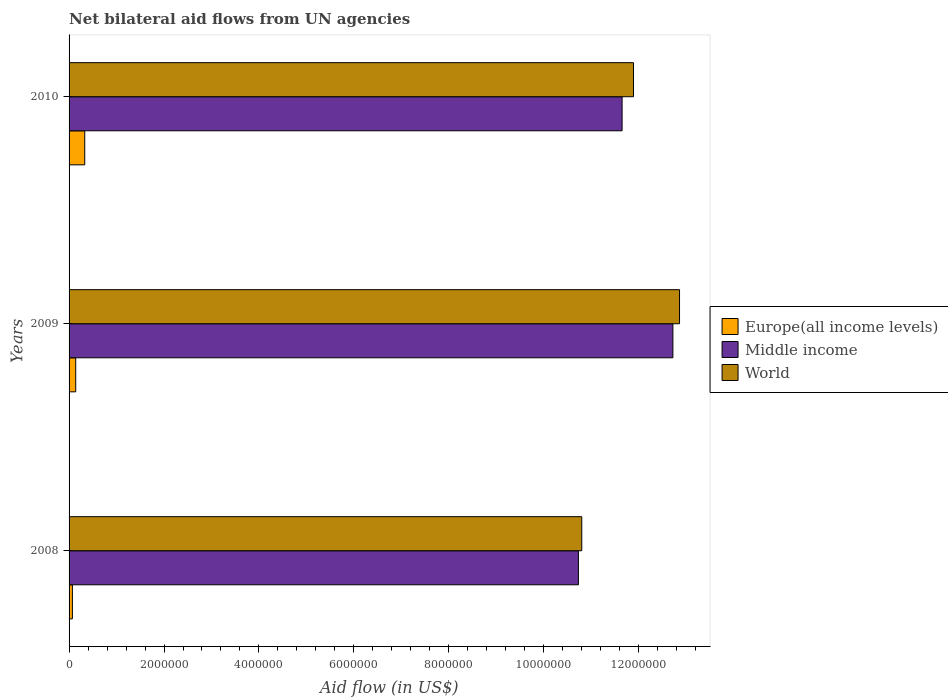Are the number of bars per tick equal to the number of legend labels?
Provide a short and direct response. Yes. Are the number of bars on each tick of the Y-axis equal?
Offer a terse response. Yes. What is the label of the 2nd group of bars from the top?
Offer a terse response. 2009. In how many cases, is the number of bars for a given year not equal to the number of legend labels?
Keep it short and to the point. 0. What is the net bilateral aid flow in Middle income in 2008?
Ensure brevity in your answer.  1.07e+07. Across all years, what is the maximum net bilateral aid flow in Europe(all income levels)?
Offer a very short reply. 3.30e+05. Across all years, what is the minimum net bilateral aid flow in World?
Make the answer very short. 1.08e+07. In which year was the net bilateral aid flow in World maximum?
Ensure brevity in your answer.  2009. What is the total net bilateral aid flow in Europe(all income levels) in the graph?
Provide a short and direct response. 5.40e+05. What is the difference between the net bilateral aid flow in Europe(all income levels) in 2008 and that in 2009?
Your answer should be compact. -7.00e+04. What is the difference between the net bilateral aid flow in World in 2010 and the net bilateral aid flow in Middle income in 2008?
Give a very brief answer. 1.16e+06. In the year 2009, what is the difference between the net bilateral aid flow in Europe(all income levels) and net bilateral aid flow in Middle income?
Offer a very short reply. -1.26e+07. In how many years, is the net bilateral aid flow in Europe(all income levels) greater than 800000 US$?
Offer a very short reply. 0. What is the ratio of the net bilateral aid flow in World in 2008 to that in 2009?
Your answer should be compact. 0.84. Is the difference between the net bilateral aid flow in Europe(all income levels) in 2009 and 2010 greater than the difference between the net bilateral aid flow in Middle income in 2009 and 2010?
Offer a very short reply. No. What is the difference between the highest and the lowest net bilateral aid flow in Europe(all income levels)?
Your answer should be compact. 2.60e+05. What does the 1st bar from the top in 2009 represents?
Your answer should be compact. World. Is it the case that in every year, the sum of the net bilateral aid flow in Europe(all income levels) and net bilateral aid flow in World is greater than the net bilateral aid flow in Middle income?
Offer a very short reply. Yes. How many bars are there?
Make the answer very short. 9. Are all the bars in the graph horizontal?
Your response must be concise. Yes. Does the graph contain any zero values?
Your answer should be compact. No. Does the graph contain grids?
Your answer should be compact. No. Where does the legend appear in the graph?
Offer a terse response. Center right. How many legend labels are there?
Your answer should be compact. 3. What is the title of the graph?
Ensure brevity in your answer.  Net bilateral aid flows from UN agencies. Does "Paraguay" appear as one of the legend labels in the graph?
Give a very brief answer. No. What is the label or title of the X-axis?
Ensure brevity in your answer.  Aid flow (in US$). What is the label or title of the Y-axis?
Your answer should be compact. Years. What is the Aid flow (in US$) of Europe(all income levels) in 2008?
Make the answer very short. 7.00e+04. What is the Aid flow (in US$) of Middle income in 2008?
Your answer should be compact. 1.07e+07. What is the Aid flow (in US$) of World in 2008?
Give a very brief answer. 1.08e+07. What is the Aid flow (in US$) of Europe(all income levels) in 2009?
Ensure brevity in your answer.  1.40e+05. What is the Aid flow (in US$) in Middle income in 2009?
Offer a very short reply. 1.27e+07. What is the Aid flow (in US$) in World in 2009?
Provide a short and direct response. 1.29e+07. What is the Aid flow (in US$) in Europe(all income levels) in 2010?
Your response must be concise. 3.30e+05. What is the Aid flow (in US$) in Middle income in 2010?
Offer a terse response. 1.16e+07. What is the Aid flow (in US$) of World in 2010?
Provide a succinct answer. 1.19e+07. Across all years, what is the maximum Aid flow (in US$) of Europe(all income levels)?
Keep it short and to the point. 3.30e+05. Across all years, what is the maximum Aid flow (in US$) of Middle income?
Give a very brief answer. 1.27e+07. Across all years, what is the maximum Aid flow (in US$) of World?
Provide a short and direct response. 1.29e+07. Across all years, what is the minimum Aid flow (in US$) in Europe(all income levels)?
Ensure brevity in your answer.  7.00e+04. Across all years, what is the minimum Aid flow (in US$) in Middle income?
Your answer should be very brief. 1.07e+07. Across all years, what is the minimum Aid flow (in US$) of World?
Provide a succinct answer. 1.08e+07. What is the total Aid flow (in US$) of Europe(all income levels) in the graph?
Your answer should be very brief. 5.40e+05. What is the total Aid flow (in US$) in Middle income in the graph?
Provide a short and direct response. 3.51e+07. What is the total Aid flow (in US$) of World in the graph?
Make the answer very short. 3.56e+07. What is the difference between the Aid flow (in US$) of Middle income in 2008 and that in 2009?
Keep it short and to the point. -1.99e+06. What is the difference between the Aid flow (in US$) of World in 2008 and that in 2009?
Offer a very short reply. -2.06e+06. What is the difference between the Aid flow (in US$) in Middle income in 2008 and that in 2010?
Keep it short and to the point. -9.20e+05. What is the difference between the Aid flow (in US$) in World in 2008 and that in 2010?
Your response must be concise. -1.09e+06. What is the difference between the Aid flow (in US$) in Middle income in 2009 and that in 2010?
Provide a short and direct response. 1.07e+06. What is the difference between the Aid flow (in US$) of World in 2009 and that in 2010?
Keep it short and to the point. 9.70e+05. What is the difference between the Aid flow (in US$) in Europe(all income levels) in 2008 and the Aid flow (in US$) in Middle income in 2009?
Provide a short and direct response. -1.26e+07. What is the difference between the Aid flow (in US$) of Europe(all income levels) in 2008 and the Aid flow (in US$) of World in 2009?
Offer a terse response. -1.28e+07. What is the difference between the Aid flow (in US$) of Middle income in 2008 and the Aid flow (in US$) of World in 2009?
Your answer should be compact. -2.13e+06. What is the difference between the Aid flow (in US$) in Europe(all income levels) in 2008 and the Aid flow (in US$) in Middle income in 2010?
Provide a short and direct response. -1.16e+07. What is the difference between the Aid flow (in US$) of Europe(all income levels) in 2008 and the Aid flow (in US$) of World in 2010?
Provide a succinct answer. -1.18e+07. What is the difference between the Aid flow (in US$) of Middle income in 2008 and the Aid flow (in US$) of World in 2010?
Keep it short and to the point. -1.16e+06. What is the difference between the Aid flow (in US$) of Europe(all income levels) in 2009 and the Aid flow (in US$) of Middle income in 2010?
Provide a succinct answer. -1.15e+07. What is the difference between the Aid flow (in US$) of Europe(all income levels) in 2009 and the Aid flow (in US$) of World in 2010?
Provide a succinct answer. -1.18e+07. What is the difference between the Aid flow (in US$) in Middle income in 2009 and the Aid flow (in US$) in World in 2010?
Your response must be concise. 8.30e+05. What is the average Aid flow (in US$) of Europe(all income levels) per year?
Make the answer very short. 1.80e+05. What is the average Aid flow (in US$) in Middle income per year?
Your answer should be very brief. 1.17e+07. What is the average Aid flow (in US$) of World per year?
Keep it short and to the point. 1.18e+07. In the year 2008, what is the difference between the Aid flow (in US$) of Europe(all income levels) and Aid flow (in US$) of Middle income?
Offer a very short reply. -1.07e+07. In the year 2008, what is the difference between the Aid flow (in US$) of Europe(all income levels) and Aid flow (in US$) of World?
Your answer should be compact. -1.07e+07. In the year 2008, what is the difference between the Aid flow (in US$) in Middle income and Aid flow (in US$) in World?
Offer a terse response. -7.00e+04. In the year 2009, what is the difference between the Aid flow (in US$) in Europe(all income levels) and Aid flow (in US$) in Middle income?
Your answer should be very brief. -1.26e+07. In the year 2009, what is the difference between the Aid flow (in US$) of Europe(all income levels) and Aid flow (in US$) of World?
Offer a terse response. -1.27e+07. In the year 2010, what is the difference between the Aid flow (in US$) of Europe(all income levels) and Aid flow (in US$) of Middle income?
Offer a terse response. -1.13e+07. In the year 2010, what is the difference between the Aid flow (in US$) of Europe(all income levels) and Aid flow (in US$) of World?
Your answer should be very brief. -1.16e+07. What is the ratio of the Aid flow (in US$) in Europe(all income levels) in 2008 to that in 2009?
Make the answer very short. 0.5. What is the ratio of the Aid flow (in US$) of Middle income in 2008 to that in 2009?
Provide a succinct answer. 0.84. What is the ratio of the Aid flow (in US$) of World in 2008 to that in 2009?
Provide a short and direct response. 0.84. What is the ratio of the Aid flow (in US$) of Europe(all income levels) in 2008 to that in 2010?
Provide a short and direct response. 0.21. What is the ratio of the Aid flow (in US$) of Middle income in 2008 to that in 2010?
Your answer should be very brief. 0.92. What is the ratio of the Aid flow (in US$) of World in 2008 to that in 2010?
Offer a very short reply. 0.91. What is the ratio of the Aid flow (in US$) in Europe(all income levels) in 2009 to that in 2010?
Your answer should be compact. 0.42. What is the ratio of the Aid flow (in US$) in Middle income in 2009 to that in 2010?
Offer a very short reply. 1.09. What is the ratio of the Aid flow (in US$) in World in 2009 to that in 2010?
Ensure brevity in your answer.  1.08. What is the difference between the highest and the second highest Aid flow (in US$) of Middle income?
Provide a succinct answer. 1.07e+06. What is the difference between the highest and the second highest Aid flow (in US$) in World?
Provide a succinct answer. 9.70e+05. What is the difference between the highest and the lowest Aid flow (in US$) of Middle income?
Offer a very short reply. 1.99e+06. What is the difference between the highest and the lowest Aid flow (in US$) in World?
Your answer should be very brief. 2.06e+06. 